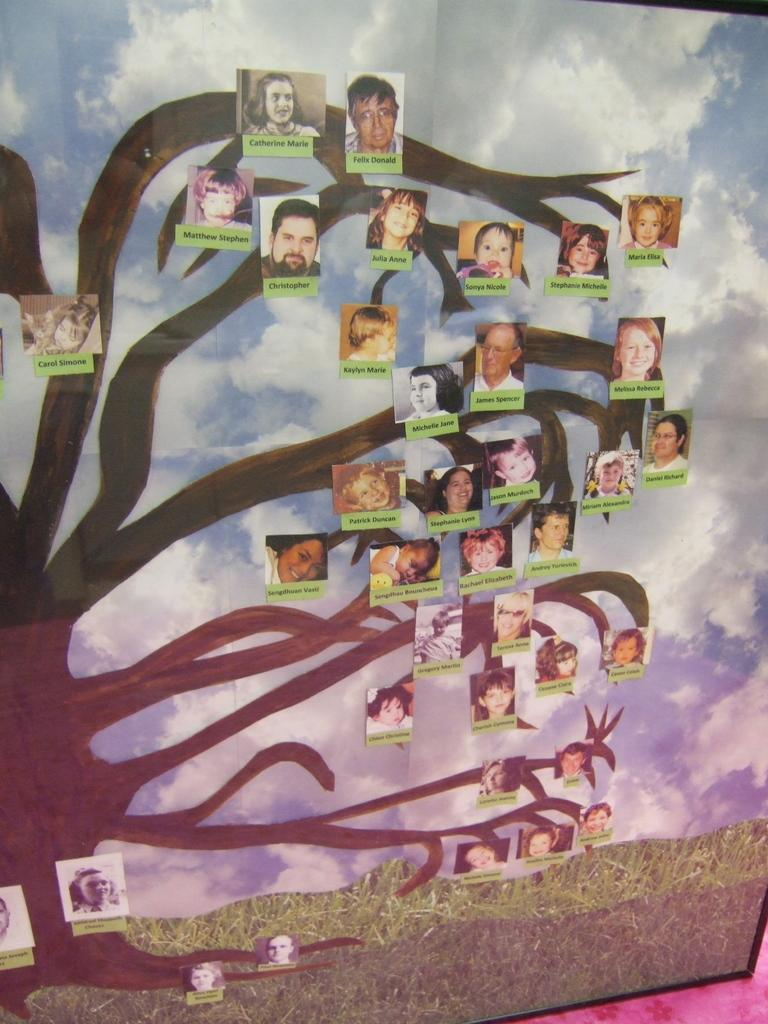What is the main subject of the image? The main subject of the image is a frame. What is inside the frame? The frame contains a tree. What is attached to the tree? Photos are attached to the tree. Are there any names associated with the photos? Yes, names of people are associated with the photos. What can be seen in the background of the image? The sky is visible in the image. What type of vegetation is present in the image? Grass is present in the image. Can you tell me how many pieces of cheese are hanging from the tree in the image? There is no cheese present in the image; the tree has photos attached to it. 